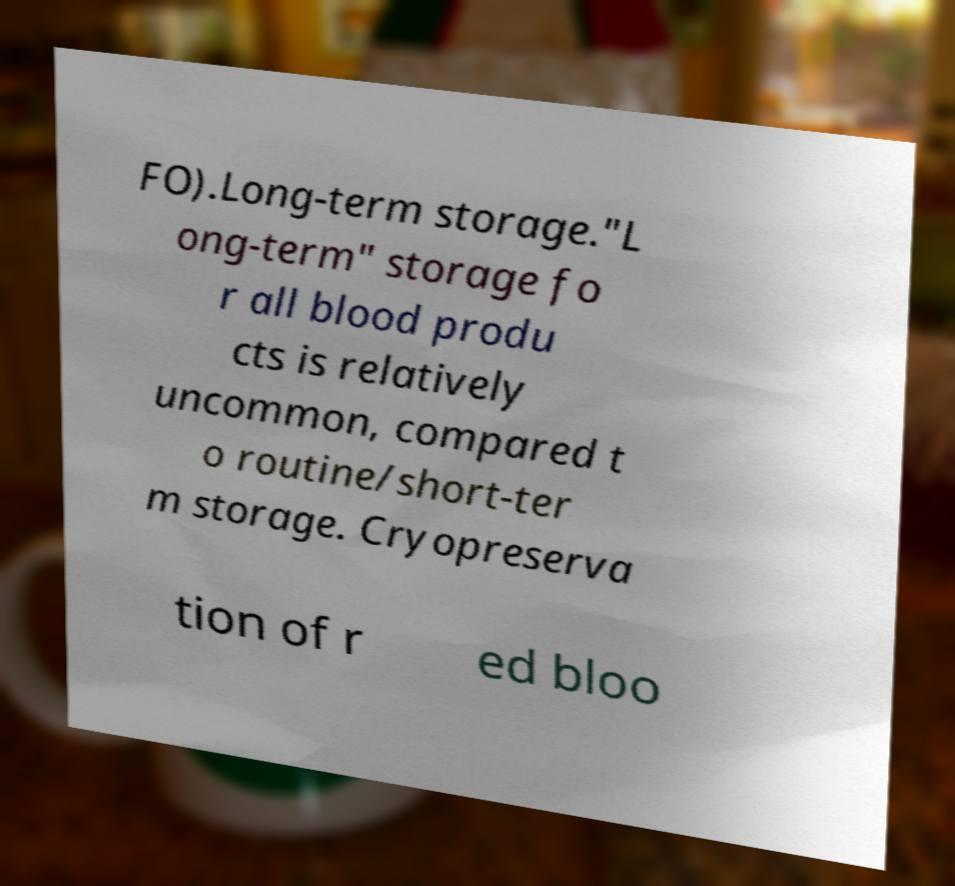For documentation purposes, I need the text within this image transcribed. Could you provide that? FO).Long-term storage."L ong-term" storage fo r all blood produ cts is relatively uncommon, compared t o routine/short-ter m storage. Cryopreserva tion of r ed bloo 